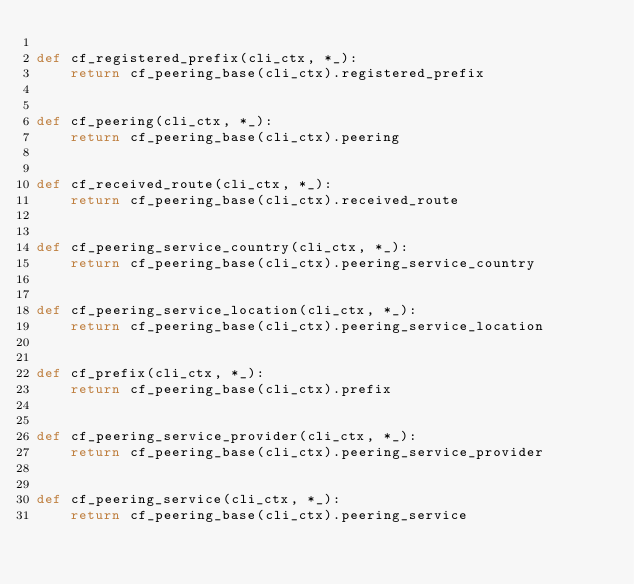Convert code to text. <code><loc_0><loc_0><loc_500><loc_500><_Python_>
def cf_registered_prefix(cli_ctx, *_):
    return cf_peering_base(cli_ctx).registered_prefix


def cf_peering(cli_ctx, *_):
    return cf_peering_base(cli_ctx).peering


def cf_received_route(cli_ctx, *_):
    return cf_peering_base(cli_ctx).received_route


def cf_peering_service_country(cli_ctx, *_):
    return cf_peering_base(cli_ctx).peering_service_country


def cf_peering_service_location(cli_ctx, *_):
    return cf_peering_base(cli_ctx).peering_service_location


def cf_prefix(cli_ctx, *_):
    return cf_peering_base(cli_ctx).prefix


def cf_peering_service_provider(cli_ctx, *_):
    return cf_peering_base(cli_ctx).peering_service_provider


def cf_peering_service(cli_ctx, *_):
    return cf_peering_base(cli_ctx).peering_service
</code> 